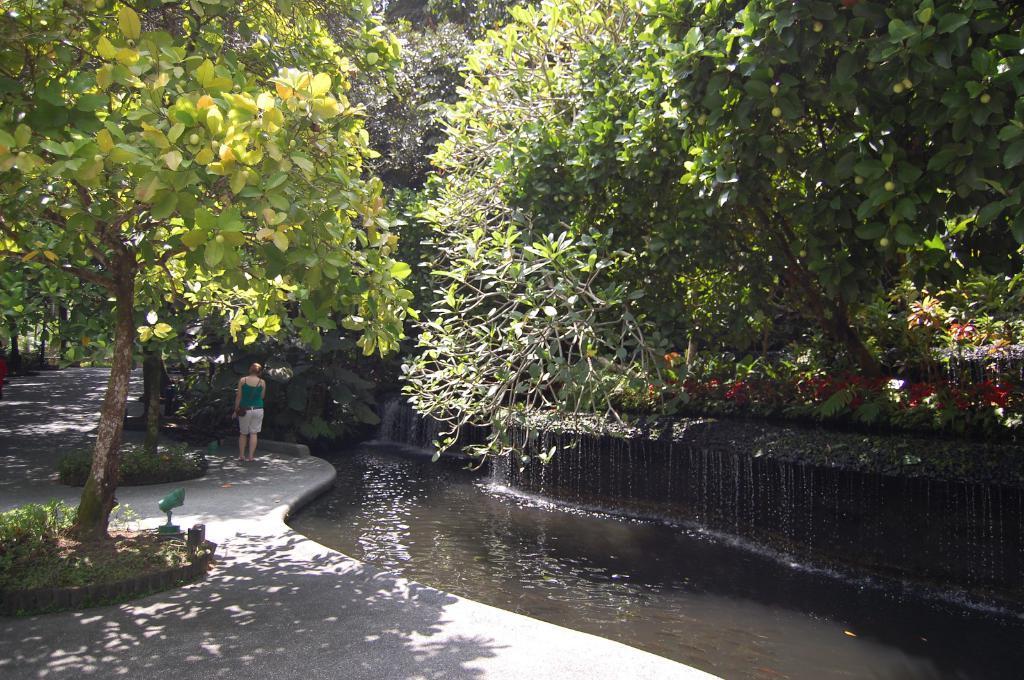Please provide a concise description of this image. In the picture I can see the water on the right side of the image and we can see a person standing on the road. Here we can see trees on the either side of the image. 